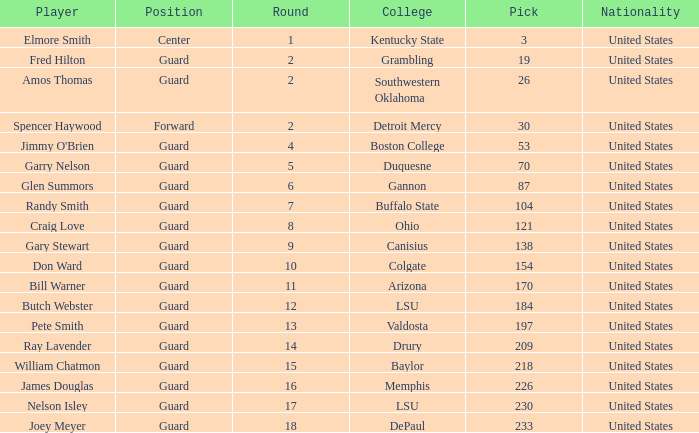WHAT IS THE TOTAL PICK FOR BOSTON COLLEGE? 1.0. Can you give me this table as a dict? {'header': ['Player', 'Position', 'Round', 'College', 'Pick', 'Nationality'], 'rows': [['Elmore Smith', 'Center', '1', 'Kentucky State', '3', 'United States'], ['Fred Hilton', 'Guard', '2', 'Grambling', '19', 'United States'], ['Amos Thomas', 'Guard', '2', 'Southwestern Oklahoma', '26', 'United States'], ['Spencer Haywood', 'Forward', '2', 'Detroit Mercy', '30', 'United States'], ["Jimmy O'Brien", 'Guard', '4', 'Boston College', '53', 'United States'], ['Garry Nelson', 'Guard', '5', 'Duquesne', '70', 'United States'], ['Glen Summors', 'Guard', '6', 'Gannon', '87', 'United States'], ['Randy Smith', 'Guard', '7', 'Buffalo State', '104', 'United States'], ['Craig Love', 'Guard', '8', 'Ohio', '121', 'United States'], ['Gary Stewart', 'Guard', '9', 'Canisius', '138', 'United States'], ['Don Ward', 'Guard', '10', 'Colgate', '154', 'United States'], ['Bill Warner', 'Guard', '11', 'Arizona', '170', 'United States'], ['Butch Webster', 'Guard', '12', 'LSU', '184', 'United States'], ['Pete Smith', 'Guard', '13', 'Valdosta', '197', 'United States'], ['Ray Lavender', 'Guard', '14', 'Drury', '209', 'United States'], ['William Chatmon', 'Guard', '15', 'Baylor', '218', 'United States'], ['James Douglas', 'Guard', '16', 'Memphis', '226', 'United States'], ['Nelson Isley', 'Guard', '17', 'LSU', '230', 'United States'], ['Joey Meyer', 'Guard', '18', 'DePaul', '233', 'United States']]} 